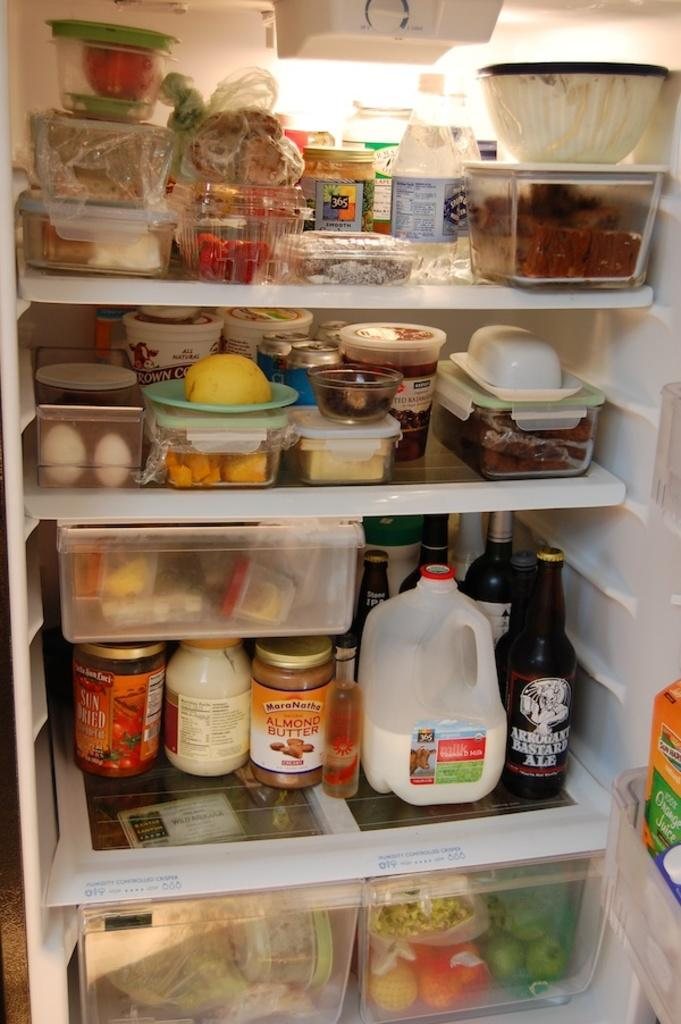<image>
Write a terse but informative summary of the picture. A fridge filled with goods with one being called Arrogant Bastard ale. 